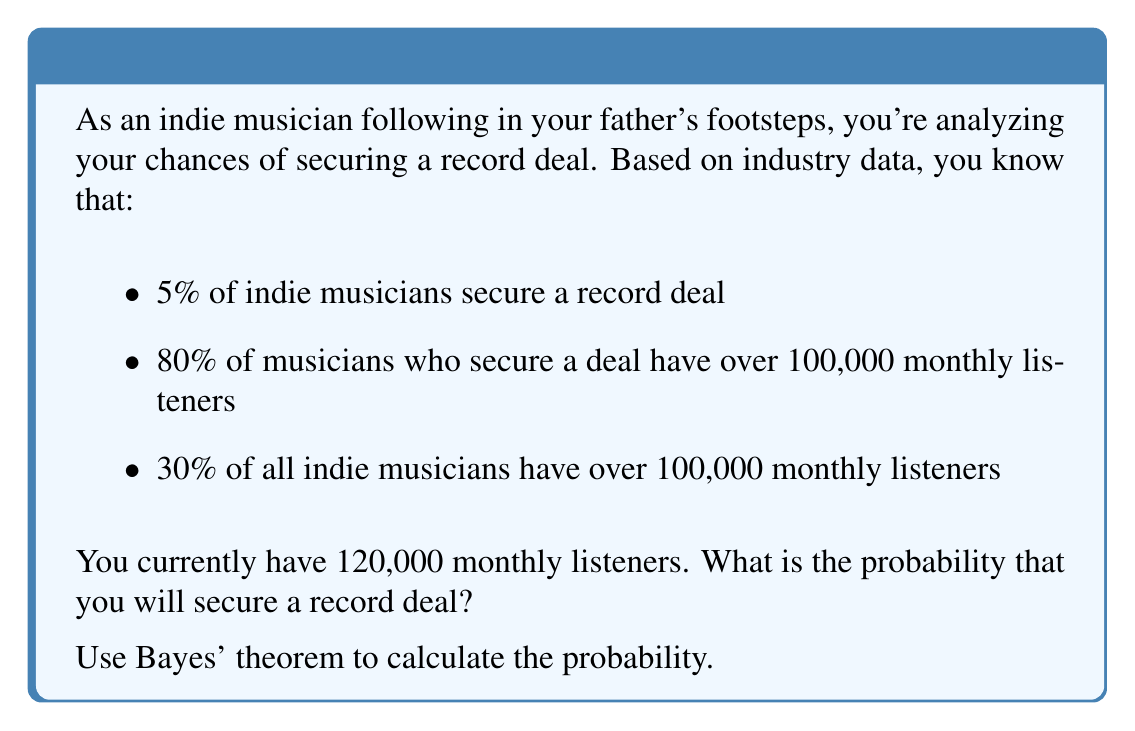Teach me how to tackle this problem. Let's approach this step-by-step using Bayes' theorem:

1) Define our events:
   A: Securing a record deal
   B: Having over 100,000 monthly listeners

2) We're given:
   $P(A) = 0.05$ (5% of indie musicians secure a deal)
   $P(B|A) = 0.80$ (80% of musicians with a deal have over 100,000 listeners)
   $P(B) = 0.30$ (30% of all indie musicians have over 100,000 listeners)

3) We want to find $P(A|B)$, the probability of securing a deal given that you have over 100,000 listeners.

4) Bayes' theorem states:

   $$P(A|B) = \frac{P(B|A) \cdot P(A)}{P(B)}$$

5) Substituting our known values:

   $$P(A|B) = \frac{0.80 \cdot 0.05}{0.30}$$

6) Calculate:
   $$P(A|B) = \frac{0.04}{0.30} = \frac{2}{15} \approx 0.1333$$

7) Convert to a percentage:
   $0.1333 \cdot 100\% = 13.33\%$

Therefore, given that you have over 100,000 monthly listeners, your probability of securing a record deal is approximately 13.33%.
Answer: 13.33% 